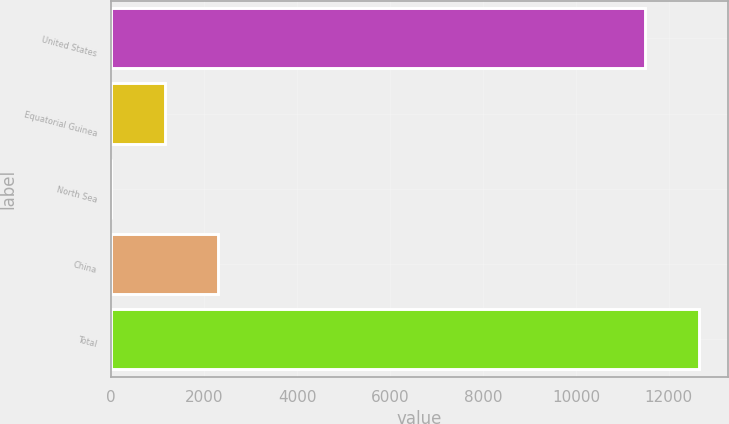Convert chart. <chart><loc_0><loc_0><loc_500><loc_500><bar_chart><fcel>United States<fcel>Equatorial Guinea<fcel>North Sea<fcel>China<fcel>Total<nl><fcel>11490.7<fcel>1156.3<fcel>5<fcel>2307.6<fcel>12642<nl></chart> 